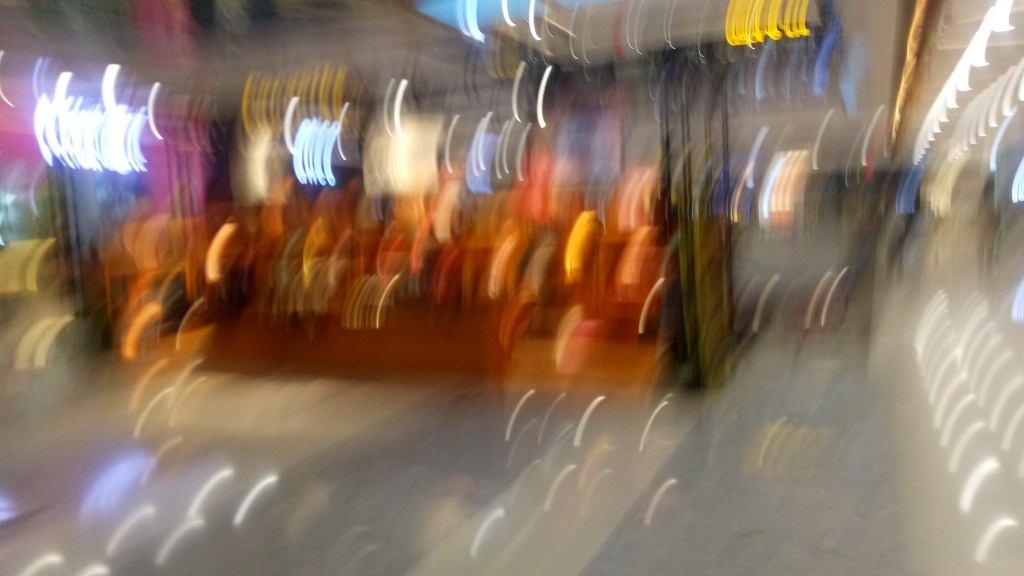Are there any quality issues with this image? Yes, the image is blurry and lacks clear focus, making it difficult to discern details such as specific objects or people. The blurriness could be due to camera movement during the exposure or an out-of-focus lens. There also seems to be overexposure in certain areas, contributing to the quality issues. 